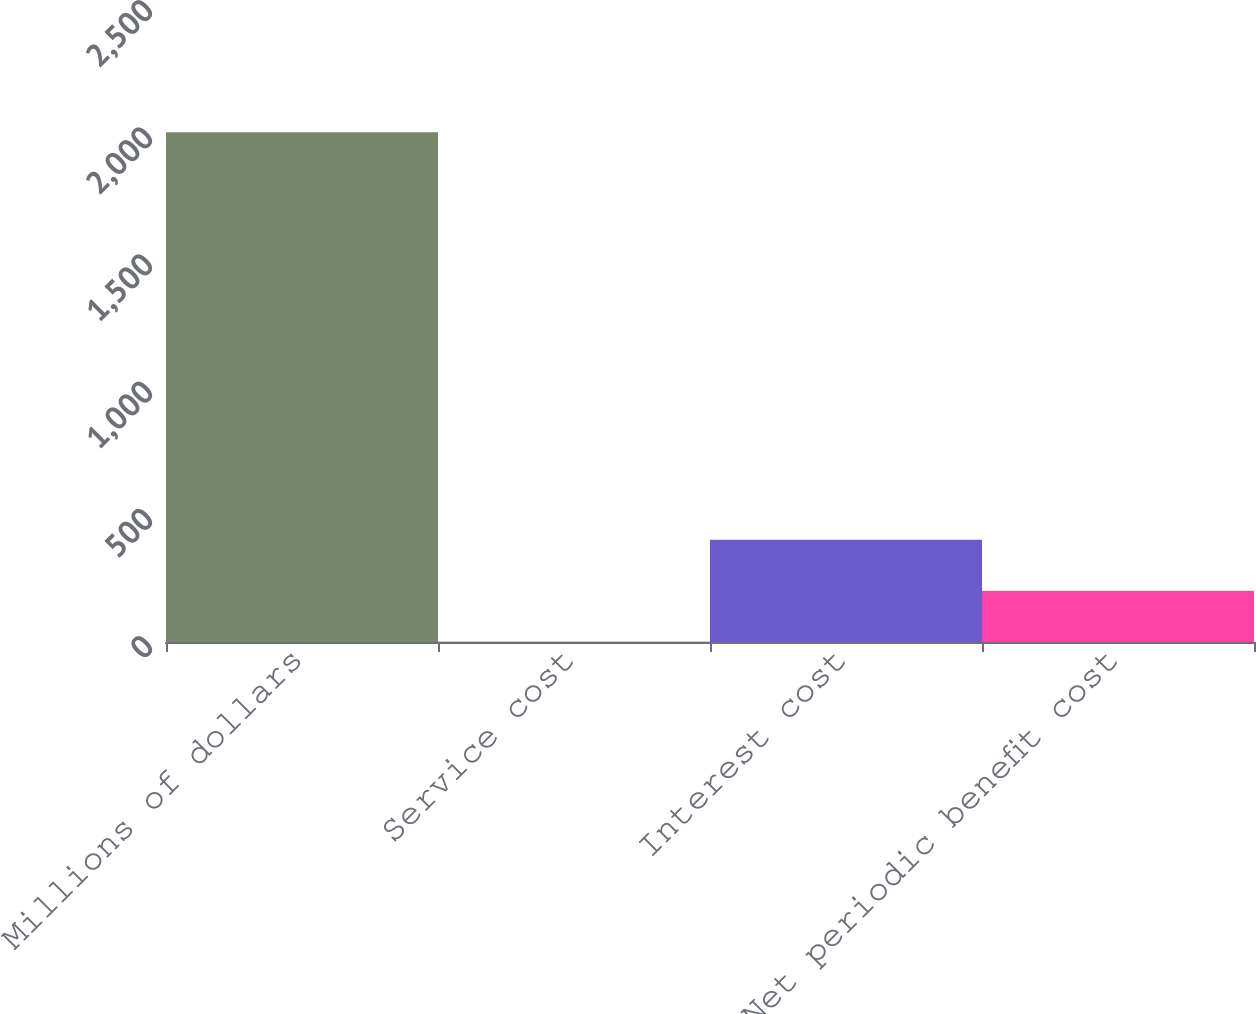Convert chart. <chart><loc_0><loc_0><loc_500><loc_500><bar_chart><fcel>Millions of dollars<fcel>Service cost<fcel>Interest cost<fcel>Net periodic benefit cost<nl><fcel>2004<fcel>1<fcel>401.6<fcel>201.3<nl></chart> 